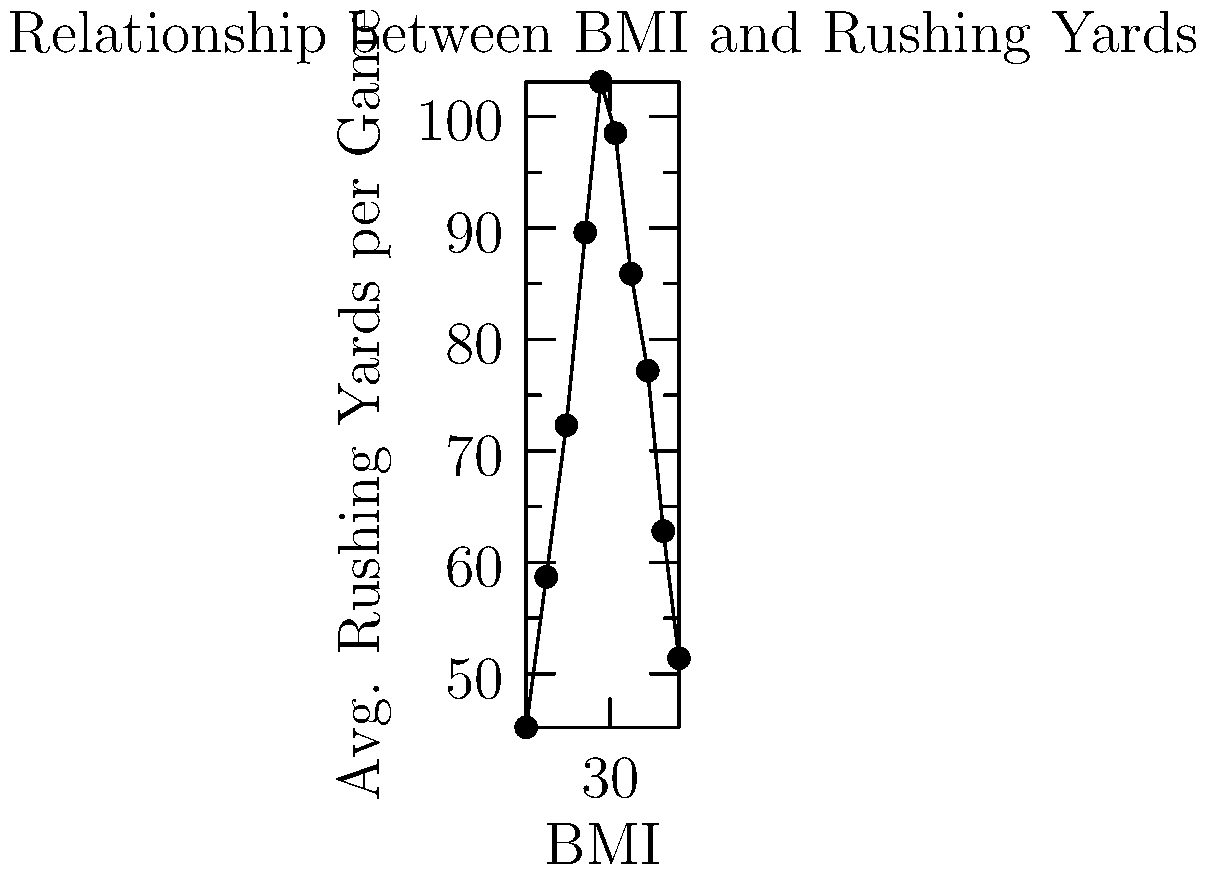Based on the scatter plot showing the relationship between players' Body Mass Index (BMI) and their average rushing yards per game, what trend can be observed as BMI increases? How might this impact a team's strategy for player selection and training? To analyze the trend in the scatter plot, we need to follow these steps:

1. Observe the overall pattern:
   The data points form a curved line rather than a straight line.

2. Identify the direction of the curve:
   As BMI increases from left to right, the average rushing yards per game initially increase, reach a peak, and then decrease.

3. Locate the peak performance:
   The highest average rushing yards appear to occur around a BMI of 29-30.

4. Analyze the trend before and after the peak:
   - Before the peak: As BMI increases from about 22 to 29, rushing yards increase.
   - After the peak: As BMI increases beyond 30, rushing yards decrease.

5. Interpret the relationship:
   This suggests an optimal BMI range for maximum rushing performance, likely balancing speed and power.

6. Consider implications for team strategy:
   - Player selection: Teams might prioritize running backs with BMIs in the 28-31 range for optimal rushing performance.
   - Training programs: Strength and conditioning staff could aim to maintain players within this optimal BMI range.
   - Position-specific strategies: Different BMI ranges might be ideal for other positions, requiring tailored approaches.

The trend indicates a quadratic or parabolic relationship between BMI and rushing performance, with an optimal range for maximum effectiveness.
Answer: Inverted U-shaped relationship; optimal BMI range (28-31) for peak rushing performance. 